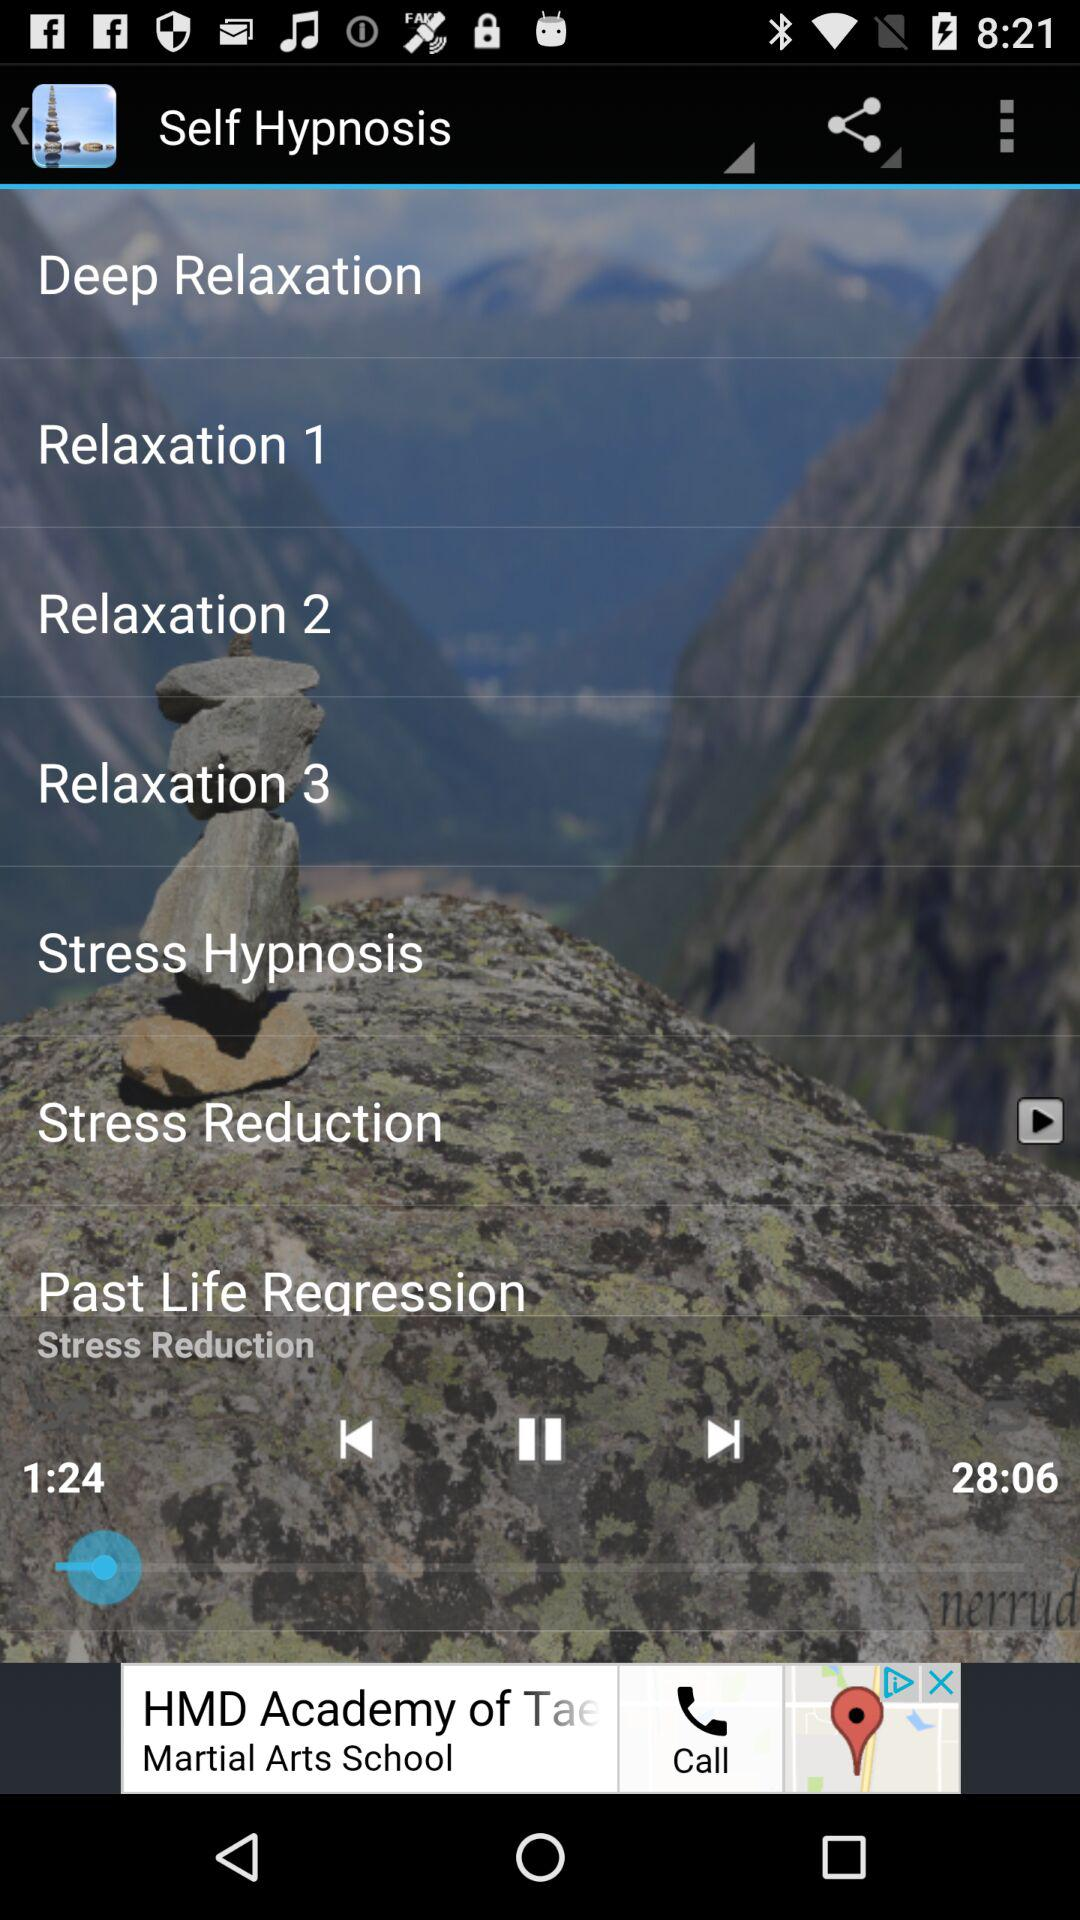What is the version of "Self Hypnosis"?
When the provided information is insufficient, respond with <no answer>. <no answer> 